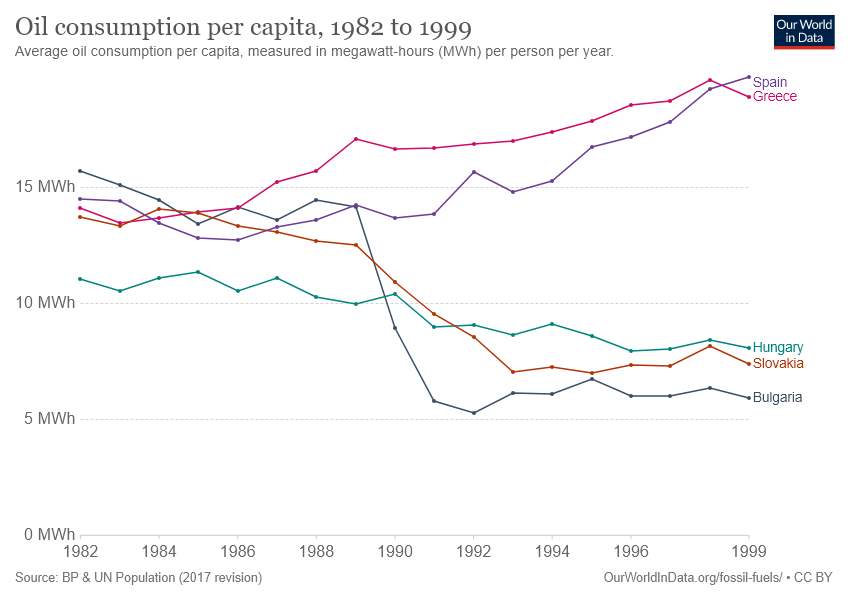List a handful of essential elements in this visual. The oil consumption per capita is highest in Greece in which year? [1996 or 1999] The number of times the dotted lines representing Spain and Bulgaria crossed each other was 1. 